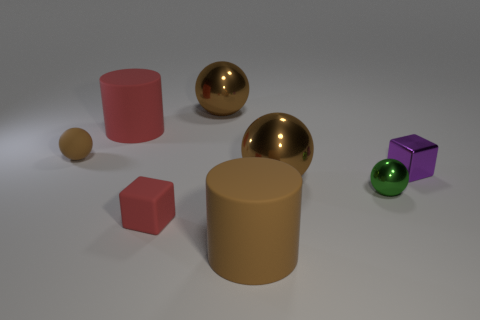Subtract all brown balls. How many were subtracted if there are1brown balls left? 2 Subtract all yellow cubes. How many brown balls are left? 3 Subtract 1 balls. How many balls are left? 3 Add 1 small metallic cubes. How many objects exist? 9 Subtract all cylinders. How many objects are left? 6 Subtract 0 yellow balls. How many objects are left? 8 Subtract all big matte cylinders. Subtract all tiny blue metal cylinders. How many objects are left? 6 Add 5 tiny red blocks. How many tiny red blocks are left? 6 Add 2 big cylinders. How many big cylinders exist? 4 